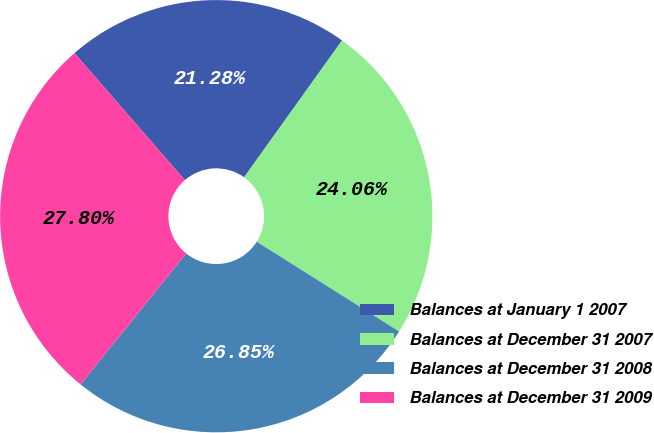Convert chart. <chart><loc_0><loc_0><loc_500><loc_500><pie_chart><fcel>Balances at January 1 2007<fcel>Balances at December 31 2007<fcel>Balances at December 31 2008<fcel>Balances at December 31 2009<nl><fcel>21.28%<fcel>24.06%<fcel>26.85%<fcel>27.8%<nl></chart> 